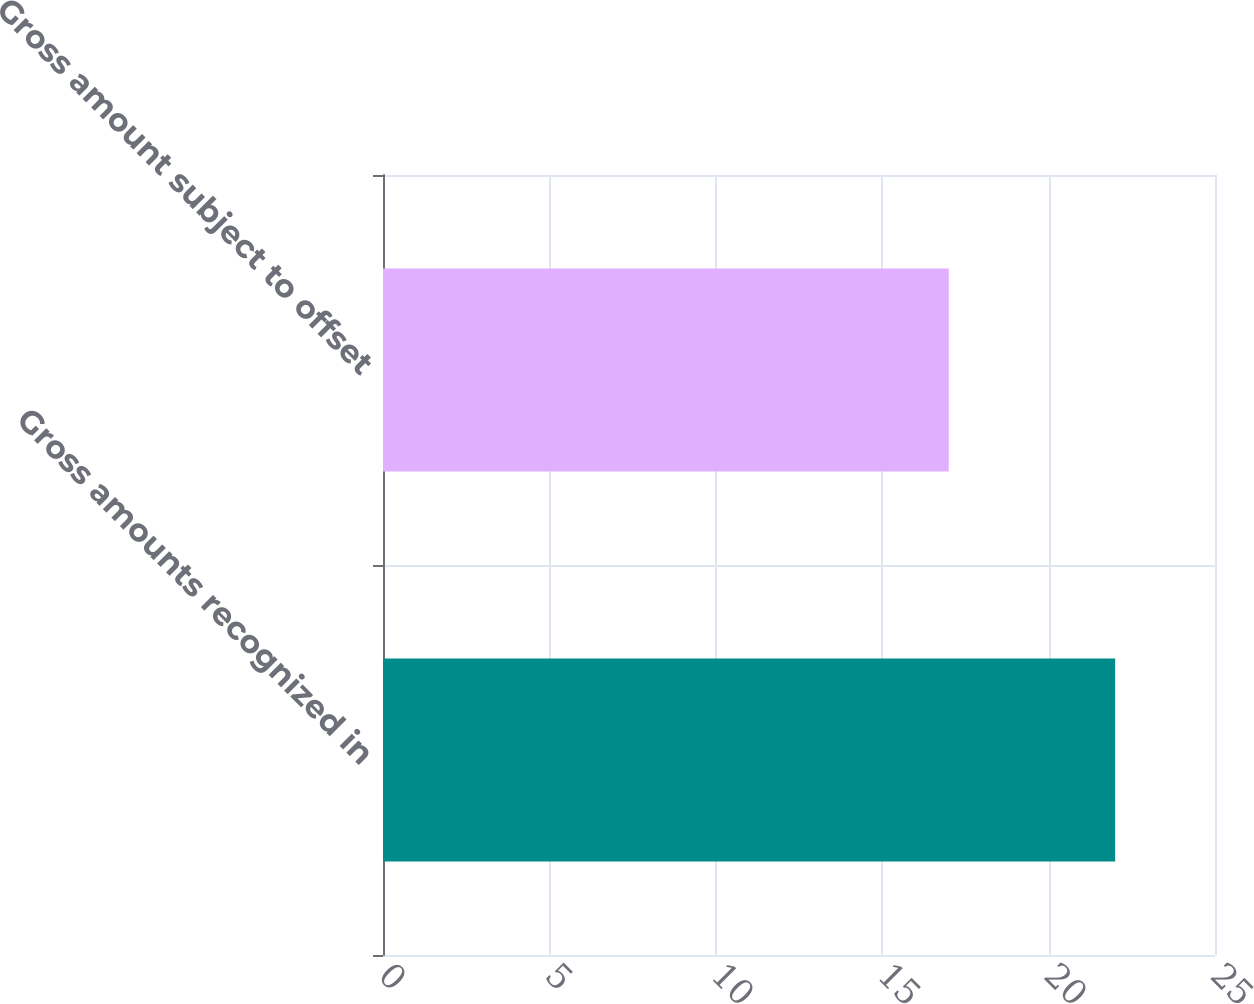<chart> <loc_0><loc_0><loc_500><loc_500><bar_chart><fcel>Gross amounts recognized in<fcel>Gross amount subject to offset<nl><fcel>22<fcel>17<nl></chart> 